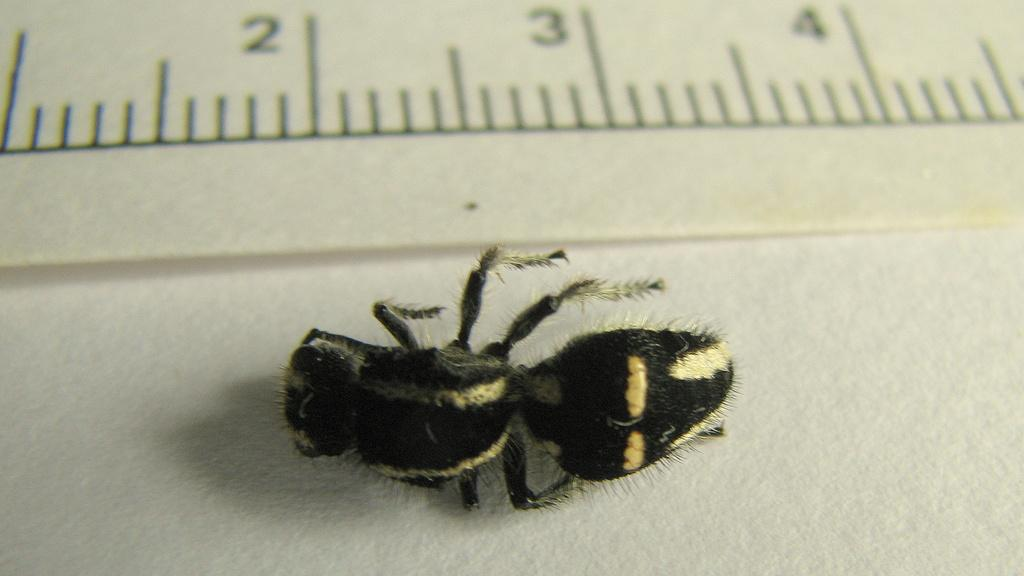What type of insect can be seen in the image? There is a bee in the image. What is the purpose of the scale marked on the paper in the image? The purpose of the scale marked on the paper is not clear from the image alone, but it could be used for measuring or recording data. Can you see the bee's toe in the image? There are no visible toes on the bee in the image, as bees do not have toes. 